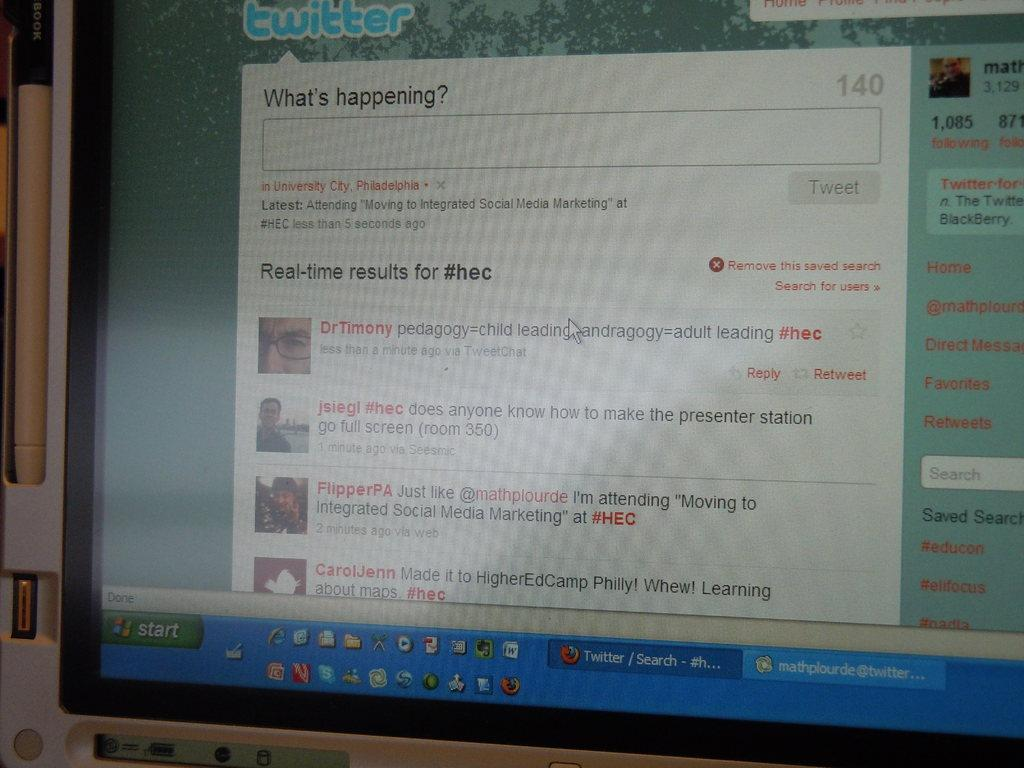<image>
Give a short and clear explanation of the subsequent image. A computer monitor displaying a twitter search page 